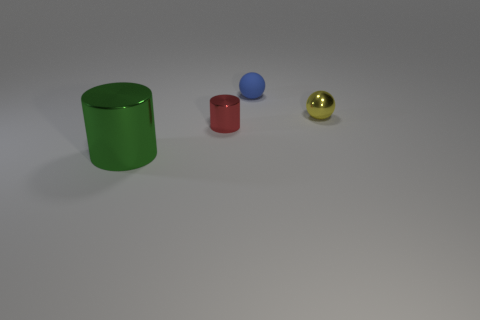Add 3 small yellow shiny spheres. How many objects exist? 7 Add 4 tiny shiny balls. How many tiny shiny balls are left? 5 Add 4 tiny metallic cylinders. How many tiny metallic cylinders exist? 5 Subtract 0 cyan cylinders. How many objects are left? 4 Subtract all green cylinders. Subtract all gray spheres. How many cylinders are left? 1 Subtract all balls. Subtract all blue objects. How many objects are left? 1 